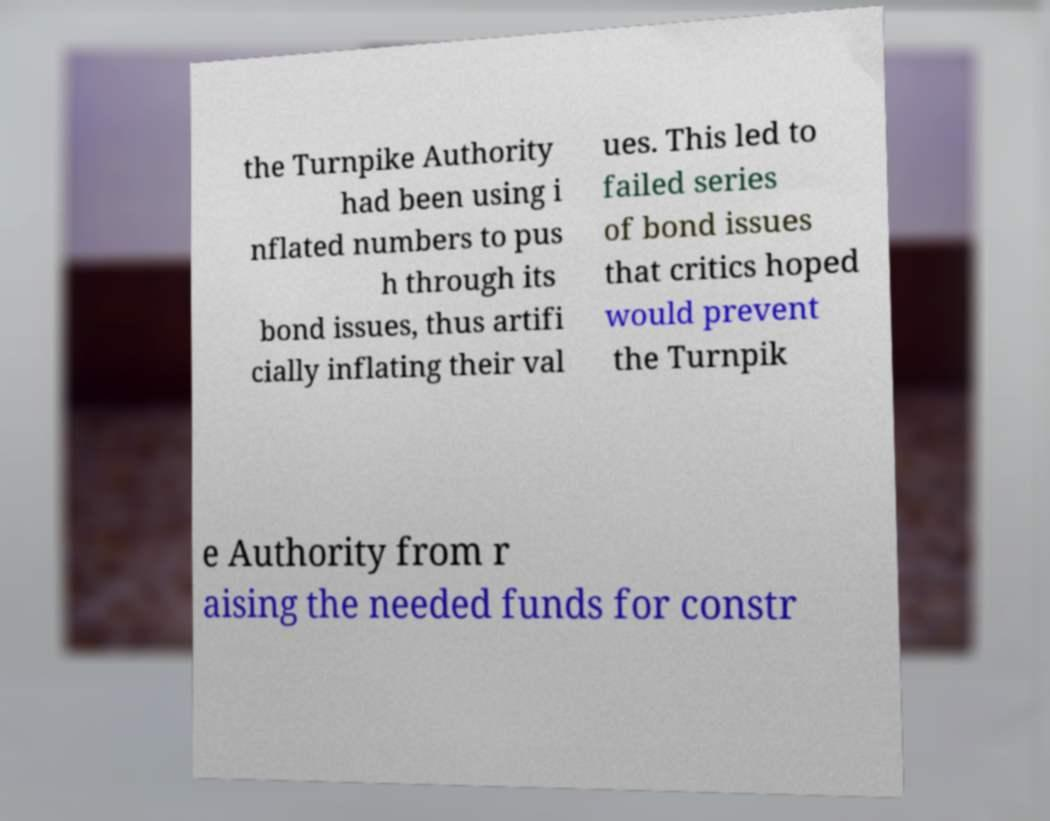Please read and relay the text visible in this image. What does it say? the Turnpike Authority had been using i nflated numbers to pus h through its bond issues, thus artifi cially inflating their val ues. This led to failed series of bond issues that critics hoped would prevent the Turnpik e Authority from r aising the needed funds for constr 